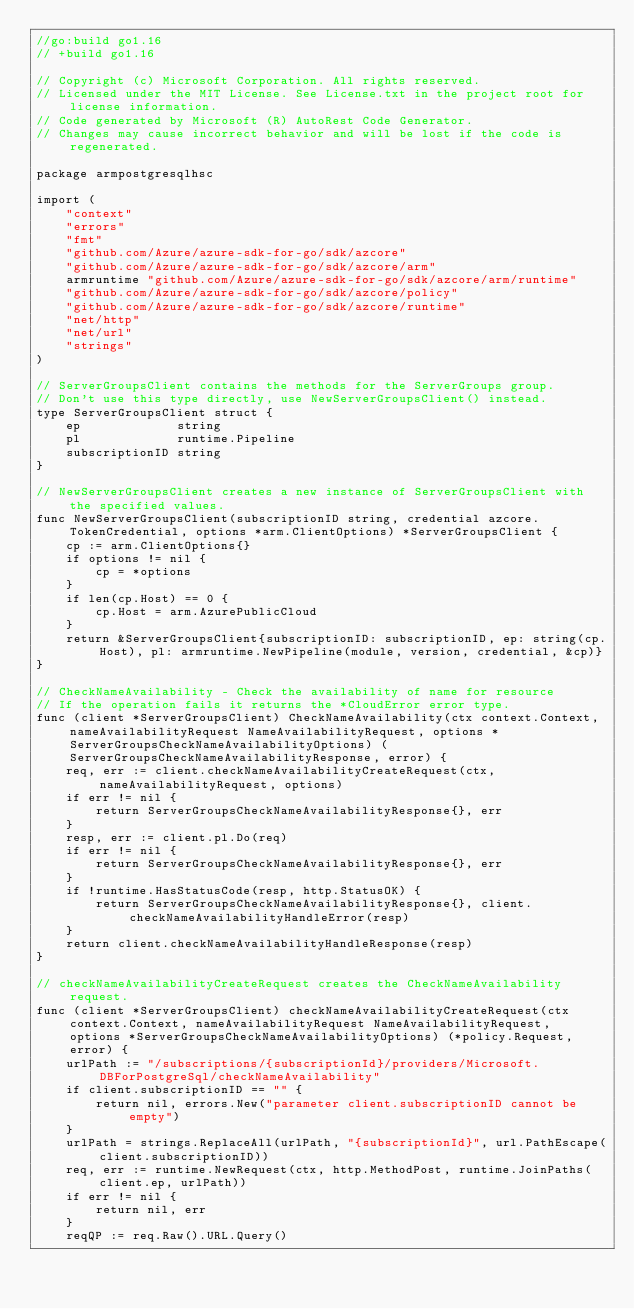<code> <loc_0><loc_0><loc_500><loc_500><_Go_>//go:build go1.16
// +build go1.16

// Copyright (c) Microsoft Corporation. All rights reserved.
// Licensed under the MIT License. See License.txt in the project root for license information.
// Code generated by Microsoft (R) AutoRest Code Generator.
// Changes may cause incorrect behavior and will be lost if the code is regenerated.

package armpostgresqlhsc

import (
	"context"
	"errors"
	"fmt"
	"github.com/Azure/azure-sdk-for-go/sdk/azcore"
	"github.com/Azure/azure-sdk-for-go/sdk/azcore/arm"
	armruntime "github.com/Azure/azure-sdk-for-go/sdk/azcore/arm/runtime"
	"github.com/Azure/azure-sdk-for-go/sdk/azcore/policy"
	"github.com/Azure/azure-sdk-for-go/sdk/azcore/runtime"
	"net/http"
	"net/url"
	"strings"
)

// ServerGroupsClient contains the methods for the ServerGroups group.
// Don't use this type directly, use NewServerGroupsClient() instead.
type ServerGroupsClient struct {
	ep             string
	pl             runtime.Pipeline
	subscriptionID string
}

// NewServerGroupsClient creates a new instance of ServerGroupsClient with the specified values.
func NewServerGroupsClient(subscriptionID string, credential azcore.TokenCredential, options *arm.ClientOptions) *ServerGroupsClient {
	cp := arm.ClientOptions{}
	if options != nil {
		cp = *options
	}
	if len(cp.Host) == 0 {
		cp.Host = arm.AzurePublicCloud
	}
	return &ServerGroupsClient{subscriptionID: subscriptionID, ep: string(cp.Host), pl: armruntime.NewPipeline(module, version, credential, &cp)}
}

// CheckNameAvailability - Check the availability of name for resource
// If the operation fails it returns the *CloudError error type.
func (client *ServerGroupsClient) CheckNameAvailability(ctx context.Context, nameAvailabilityRequest NameAvailabilityRequest, options *ServerGroupsCheckNameAvailabilityOptions) (ServerGroupsCheckNameAvailabilityResponse, error) {
	req, err := client.checkNameAvailabilityCreateRequest(ctx, nameAvailabilityRequest, options)
	if err != nil {
		return ServerGroupsCheckNameAvailabilityResponse{}, err
	}
	resp, err := client.pl.Do(req)
	if err != nil {
		return ServerGroupsCheckNameAvailabilityResponse{}, err
	}
	if !runtime.HasStatusCode(resp, http.StatusOK) {
		return ServerGroupsCheckNameAvailabilityResponse{}, client.checkNameAvailabilityHandleError(resp)
	}
	return client.checkNameAvailabilityHandleResponse(resp)
}

// checkNameAvailabilityCreateRequest creates the CheckNameAvailability request.
func (client *ServerGroupsClient) checkNameAvailabilityCreateRequest(ctx context.Context, nameAvailabilityRequest NameAvailabilityRequest, options *ServerGroupsCheckNameAvailabilityOptions) (*policy.Request, error) {
	urlPath := "/subscriptions/{subscriptionId}/providers/Microsoft.DBForPostgreSql/checkNameAvailability"
	if client.subscriptionID == "" {
		return nil, errors.New("parameter client.subscriptionID cannot be empty")
	}
	urlPath = strings.ReplaceAll(urlPath, "{subscriptionId}", url.PathEscape(client.subscriptionID))
	req, err := runtime.NewRequest(ctx, http.MethodPost, runtime.JoinPaths(client.ep, urlPath))
	if err != nil {
		return nil, err
	}
	reqQP := req.Raw().URL.Query()</code> 